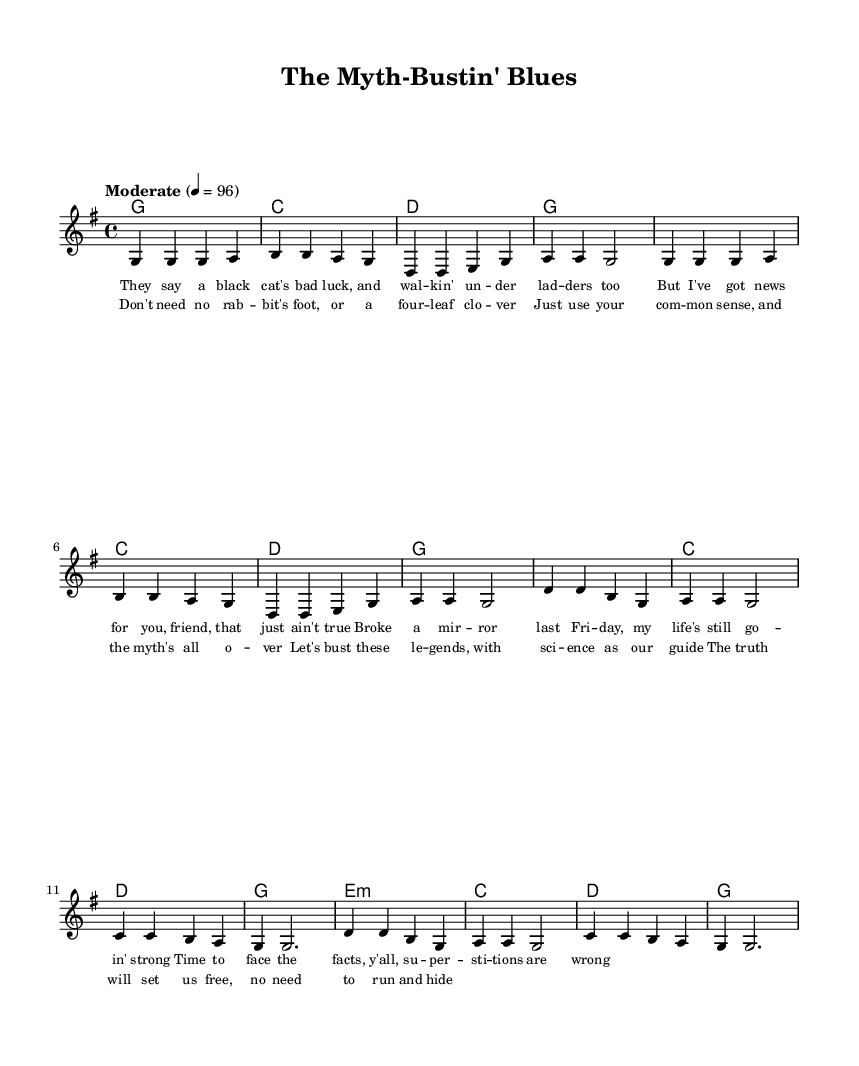What is the key signature of this music? The key signature is G major, which has one sharp (F#). This is indicated at the beginning of the staff.
Answer: G major What is the time signature of the piece? The time signature is 4/4, which means there are four beats in each measure. This is indicated at the beginning of the music notation.
Answer: 4/4 What tempo is indicated for the piece? The tempo is marked as "Moderate" with a metronome marking of 96 beats per minute, providing a guideline for the pace of the music.
Answer: Moderate 96 How many measures are there in the verse? There are eight measures in the verse section, as counted from the beginning of the verse section to its end.
Answer: 8 Which line contains the chorus? The chorus is located after the verse and can be distinctively identified by the lyrics "Don't need no rab -- bit's foot..." that follow the melody notation.
Answer: Following the verse What is the lyrical theme of the song? The lyrics discuss debunking popular superstitions, specifically mentioning black cats, broken mirrors, and other myths, emphasizing a rational viewpoint.
Answer: Debunking superstitions What chord follows the melody after the first verse? The chord that follows the melody after the first verse is G major, as indicated in the harmonies section immediately following the verse.
Answer: G 